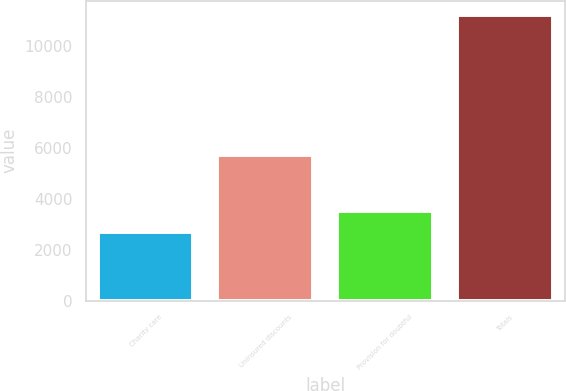Convert chart to OTSL. <chart><loc_0><loc_0><loc_500><loc_500><bar_chart><fcel>Charity care<fcel>Uninsured discounts<fcel>Provision for doubtful<fcel>Totals<nl><fcel>2683<fcel>5707<fcel>3536.1<fcel>11214<nl></chart> 